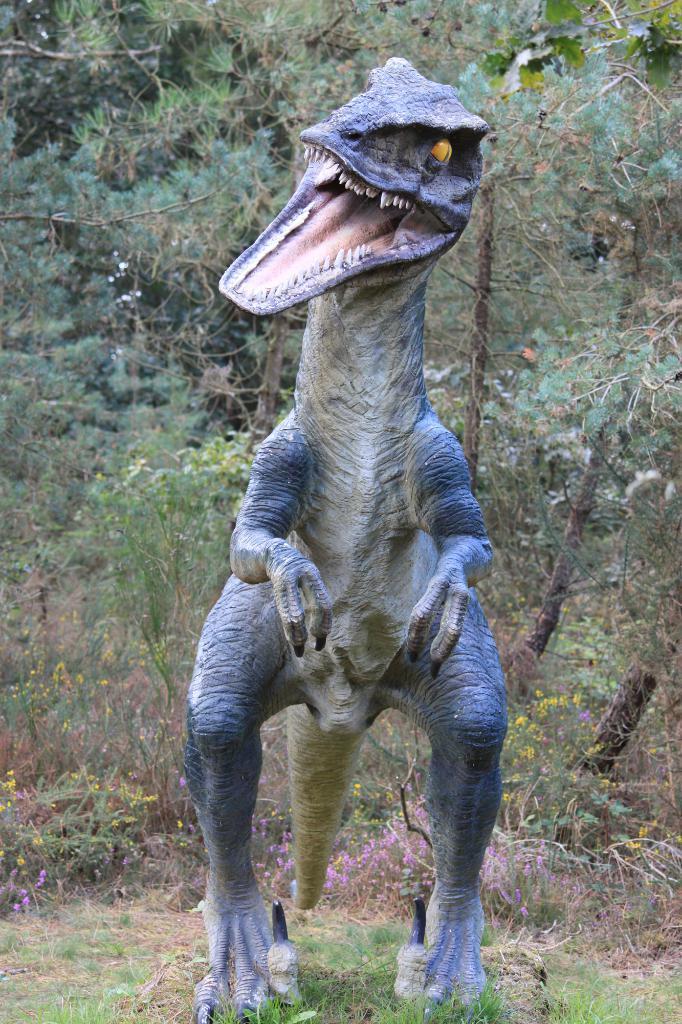Please provide a concise description of this image. In the image we can see the sculpture, grass and plants. 